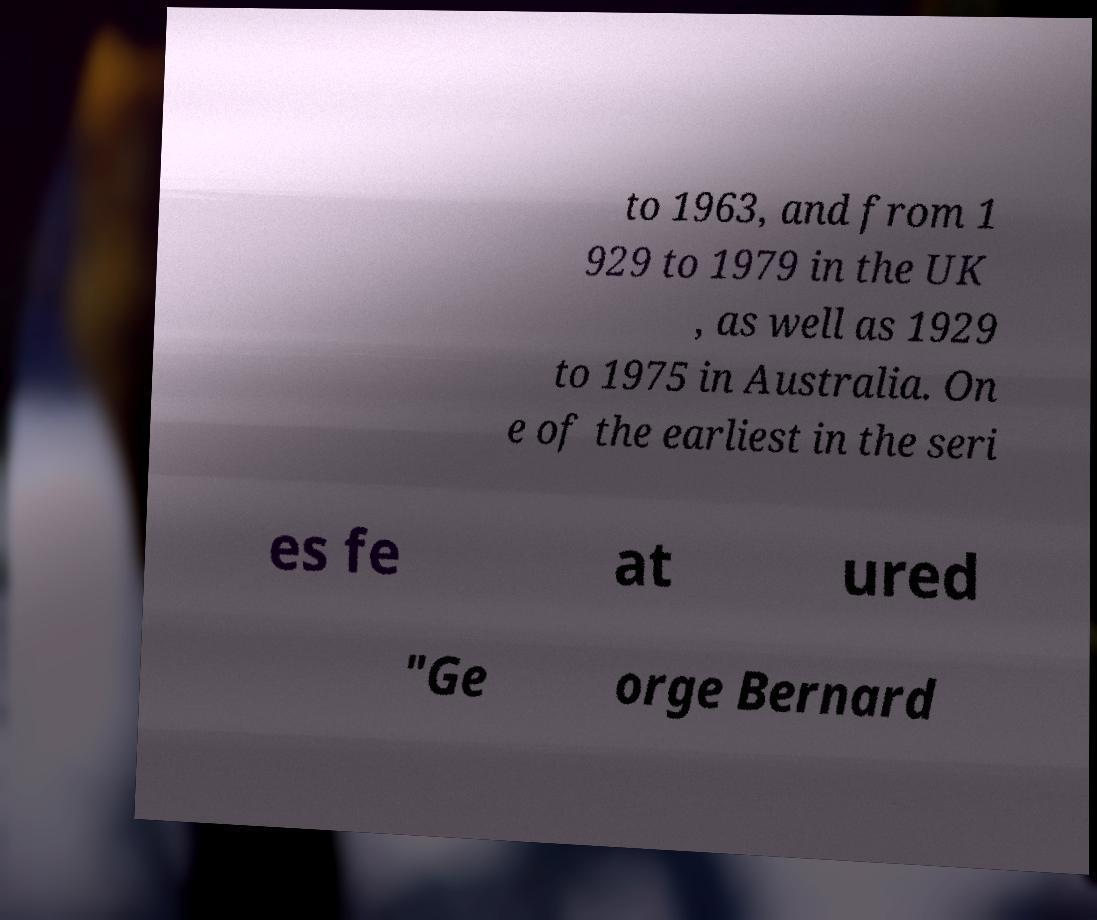Could you extract and type out the text from this image? to 1963, and from 1 929 to 1979 in the UK , as well as 1929 to 1975 in Australia. On e of the earliest in the seri es fe at ured "Ge orge Bernard 